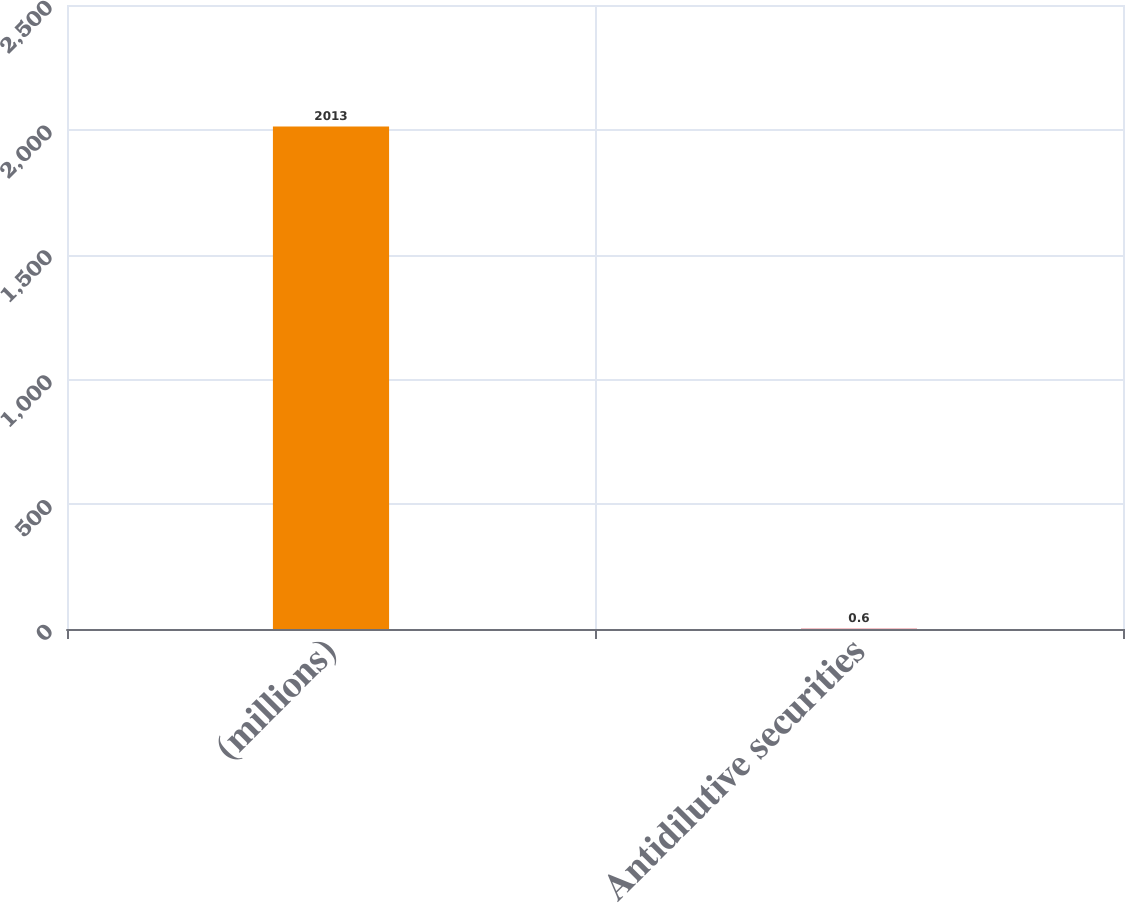Convert chart to OTSL. <chart><loc_0><loc_0><loc_500><loc_500><bar_chart><fcel>(millions)<fcel>Antidilutive securities<nl><fcel>2013<fcel>0.6<nl></chart> 